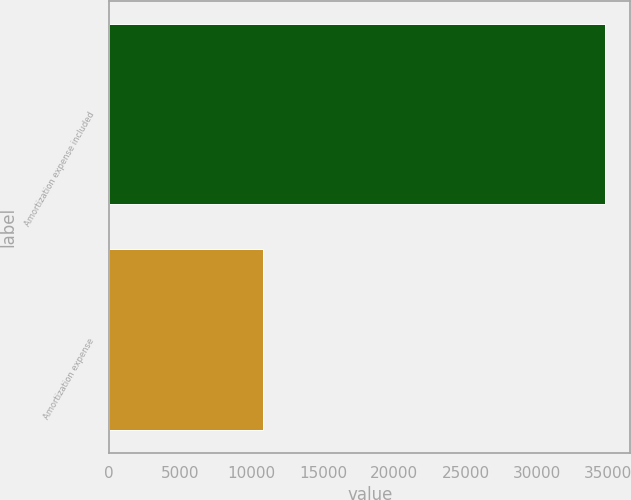<chart> <loc_0><loc_0><loc_500><loc_500><bar_chart><fcel>Amortization expense included<fcel>Amortization expense<nl><fcel>34806<fcel>10784<nl></chart> 